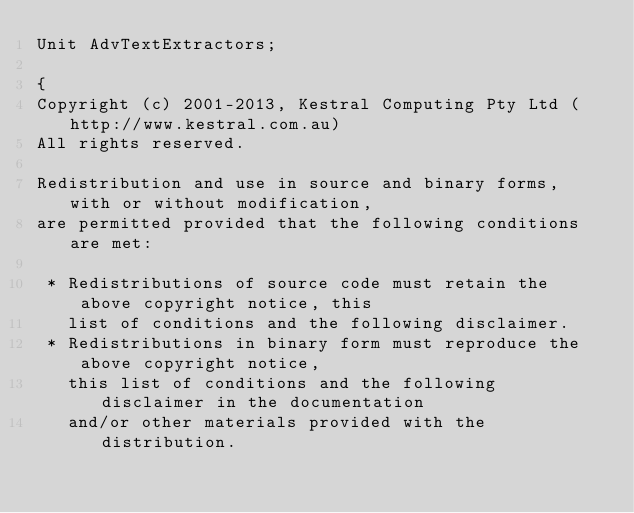Convert code to text. <code><loc_0><loc_0><loc_500><loc_500><_Pascal_>Unit AdvTextExtractors;

{
Copyright (c) 2001-2013, Kestral Computing Pty Ltd (http://www.kestral.com.au)
All rights reserved.

Redistribution and use in source and binary forms, with or without modification, 
are permitted provided that the following conditions are met:

 * Redistributions of source code must retain the above copyright notice, this 
   list of conditions and the following disclaimer.
 * Redistributions in binary form must reproduce the above copyright notice, 
   this list of conditions and the following disclaimer in the documentation 
   and/or other materials provided with the distribution.</code> 